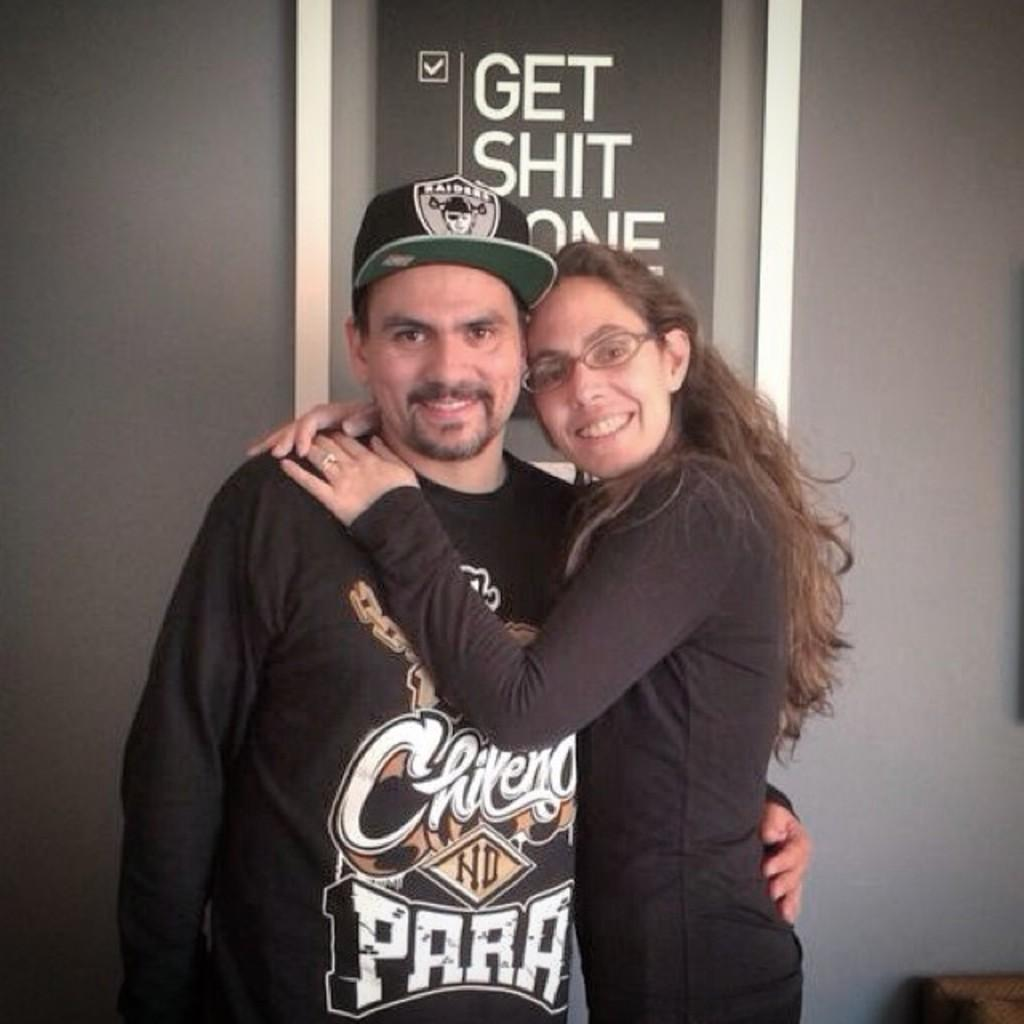<image>
Describe the image concisely. Man wearing black sweater that says "para" posing for a photo. 